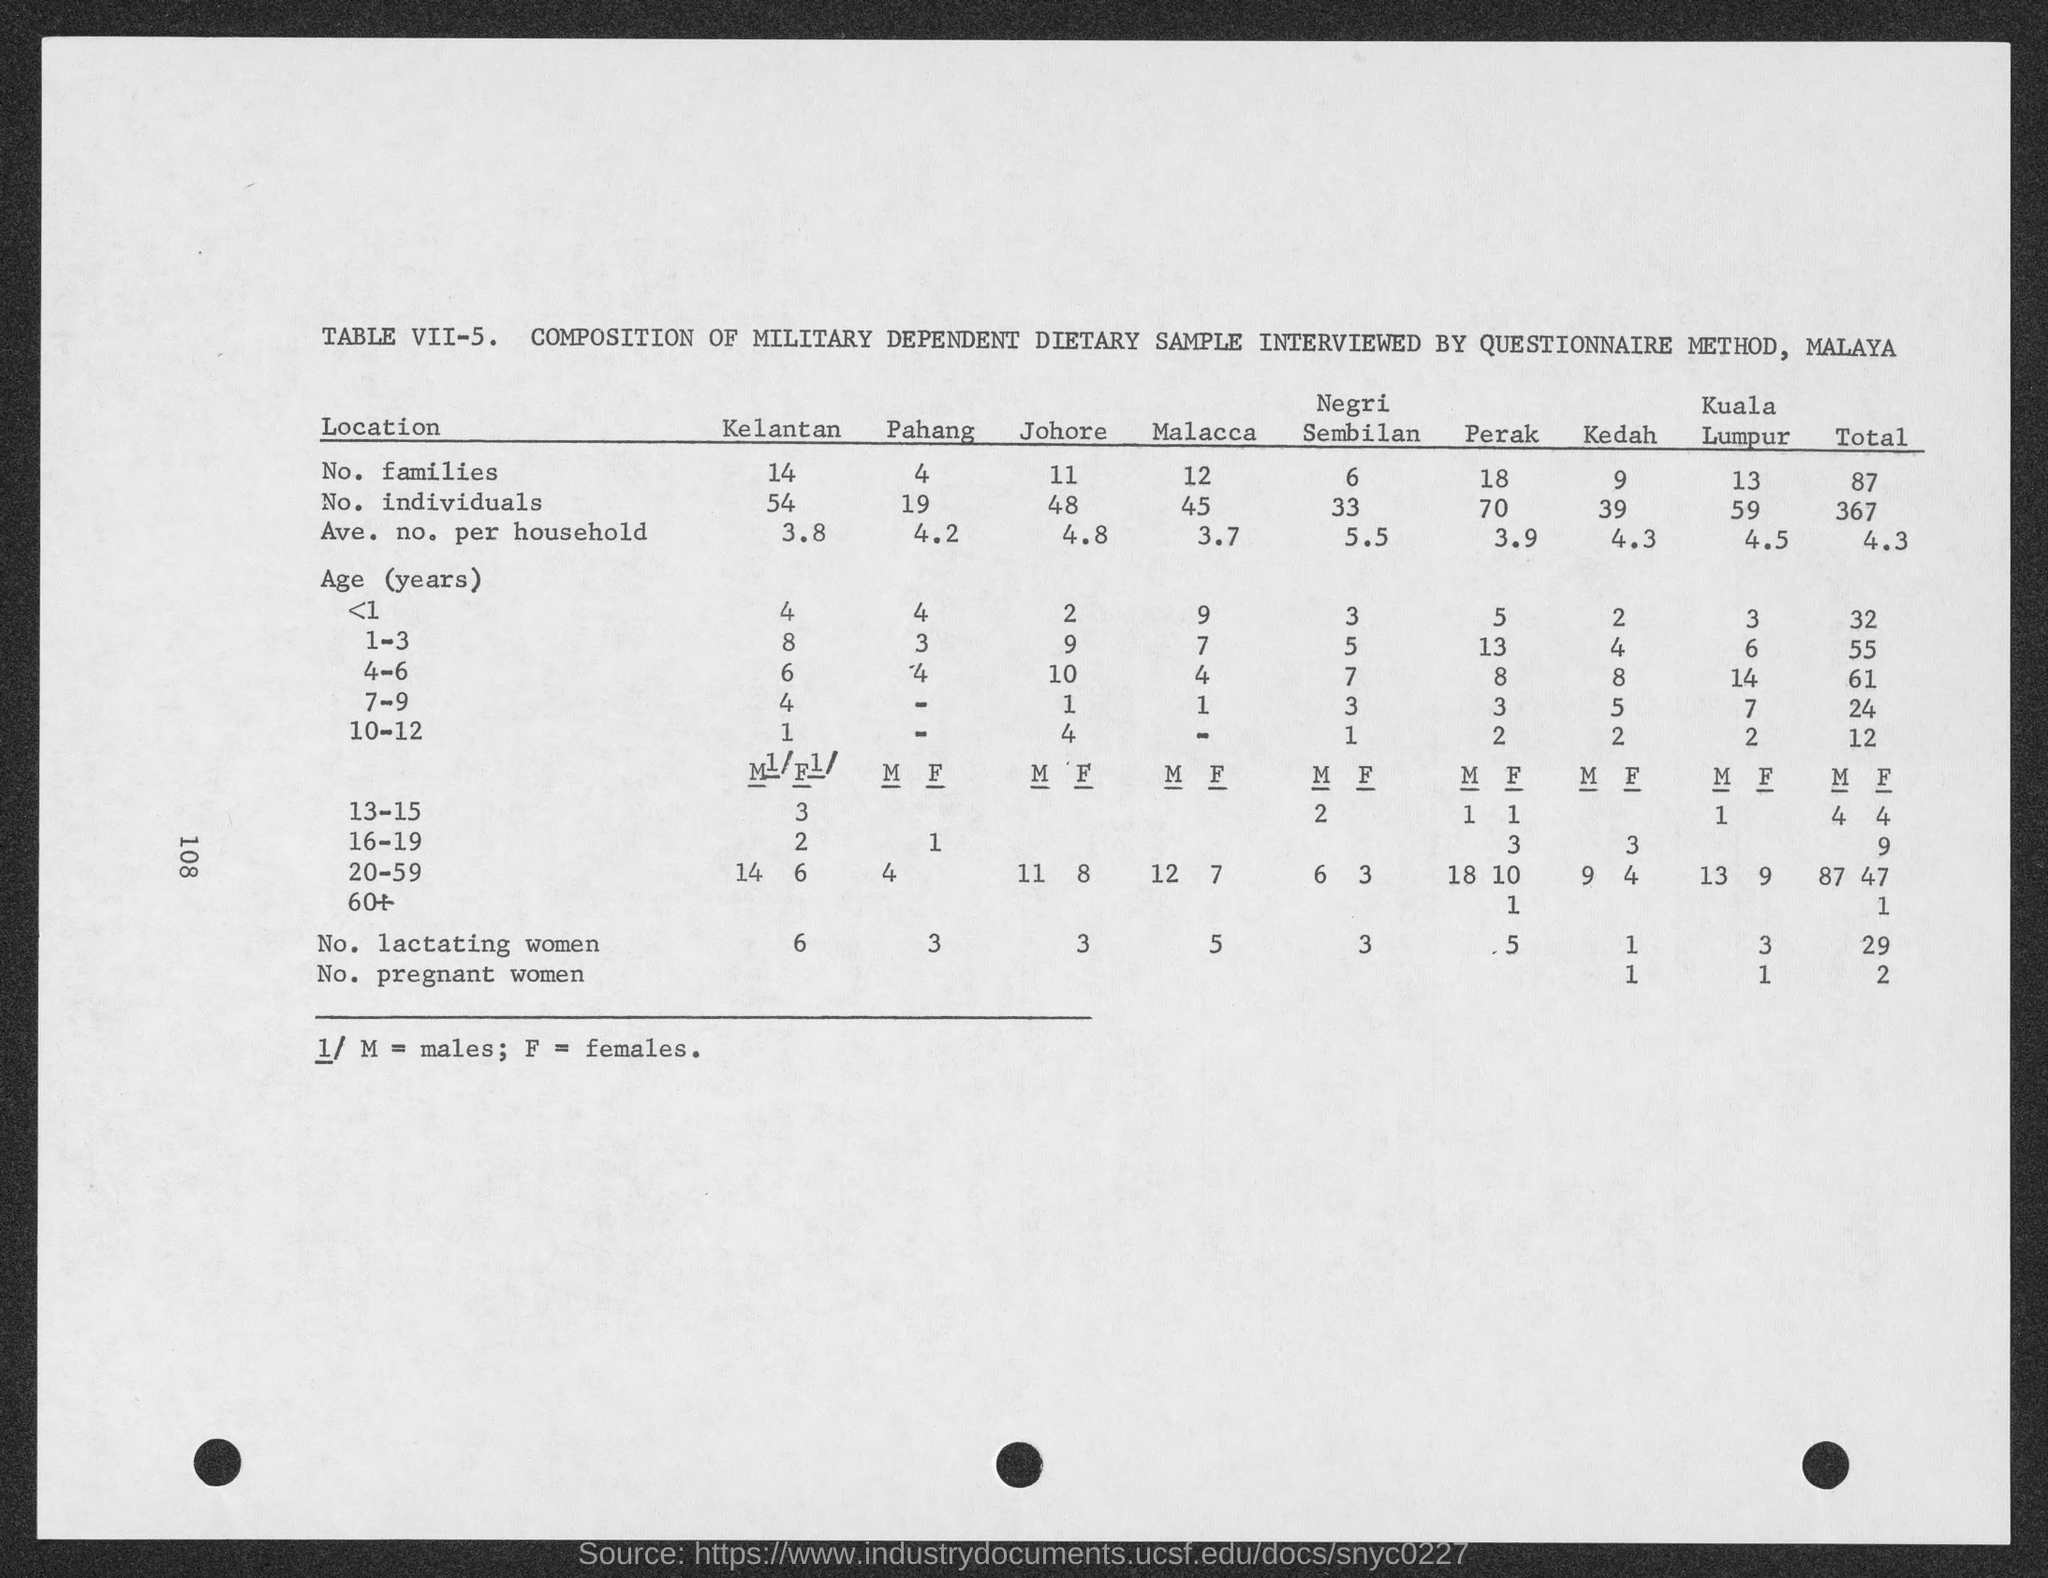How does the average number of individuals per household compare between the various locations? Examining the table, the average number of individuals per household ranges from 3.7 in Malacca to 5.5 in Negeri Sembilan. It signifies a variation in household size with Negeri Sembilan having the largest average family size and Malacca, the smallest as per the sampled data.  What does the data suggest about the differences in the number of lactating women across the locations? The table shows that the number of lactating women varies significantly among the locations, with highest in Kelantan at 6 and at least 3 locations having only 1. This could reflect different population structures or cultural practices affecting the number of women who are currently breastfeeding in each location. 